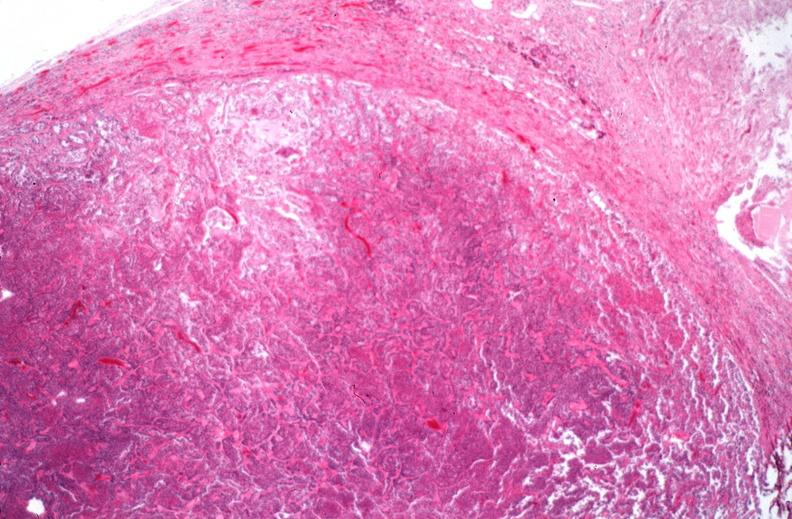what does this image show?
Answer the question using a single word or phrase. Pituitary 